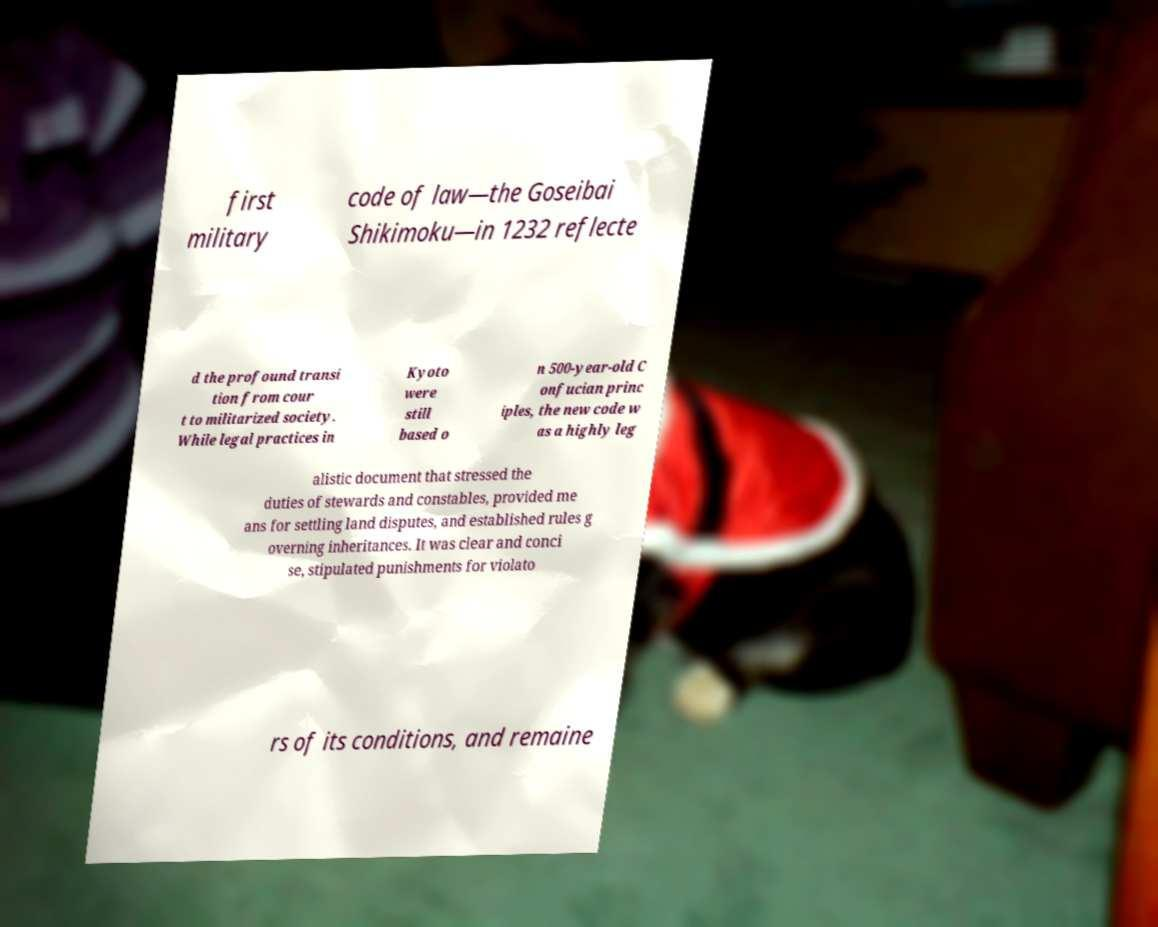Please read and relay the text visible in this image. What does it say? first military code of law—the Goseibai Shikimoku—in 1232 reflecte d the profound transi tion from cour t to militarized society. While legal practices in Kyoto were still based o n 500-year-old C onfucian princ iples, the new code w as a highly leg alistic document that stressed the duties of stewards and constables, provided me ans for settling land disputes, and established rules g overning inheritances. It was clear and conci se, stipulated punishments for violato rs of its conditions, and remaine 